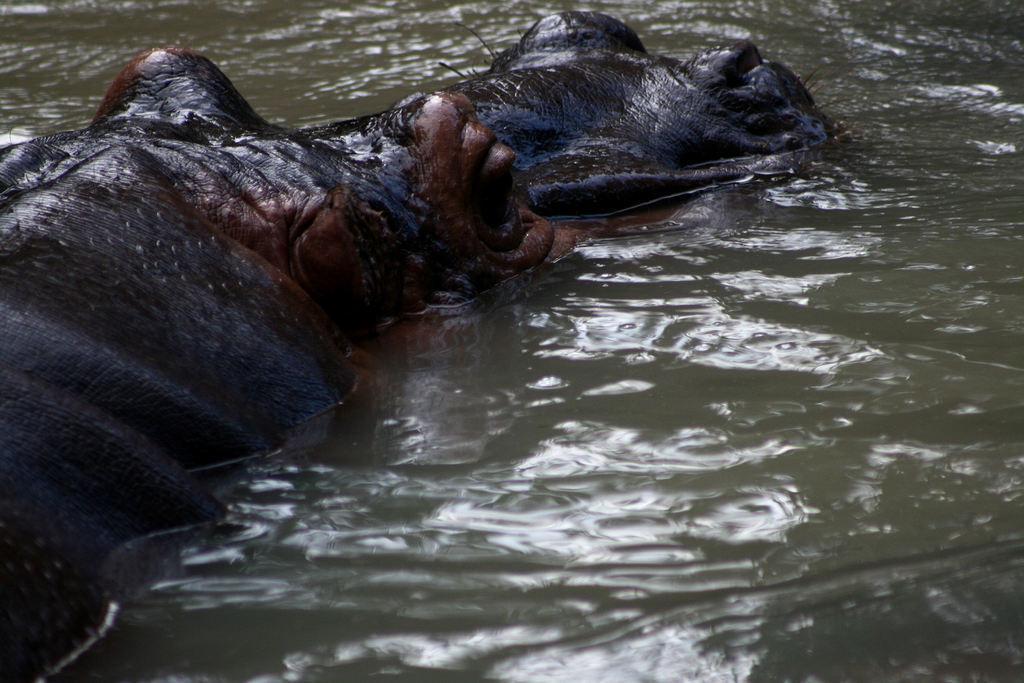How would you summarize this image in a sentence or two? In the image there is a hippopotamus in the water. 